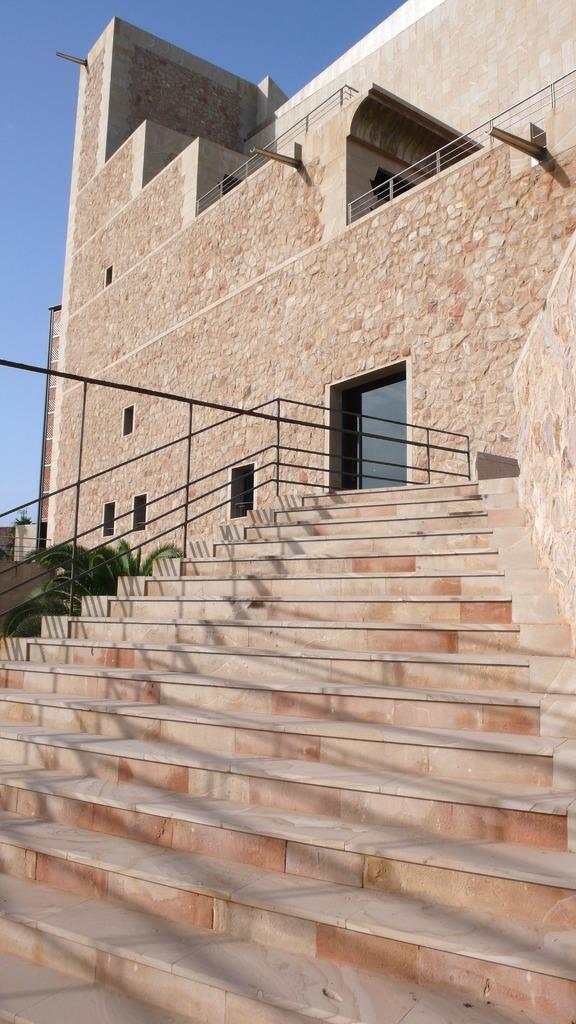What type of architectural feature can be seen in the image? There are steps in the image. Are there any safety features associated with the steps? Yes, there are railings in the image. What structure is visible in the background? There is a building in the image. What type of vegetation is present in the image? There is a plant in the image. What can be seen above the building and plant? The sky is visible in the image. What type of sponge can be seen absorbing sound in the image? There is no sponge or sound absorption depicted in the image. What type of beam is supporting the building in the image? The image does not show any specific beams supporting the building; it only shows the building's exterior. 